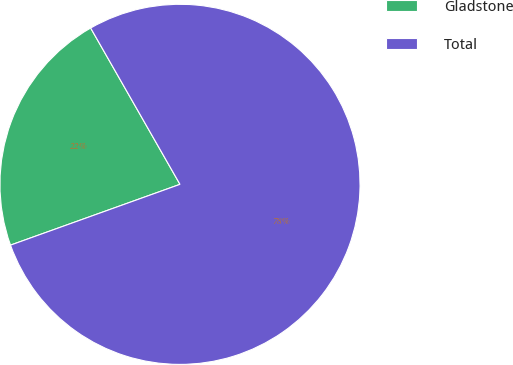Convert chart to OTSL. <chart><loc_0><loc_0><loc_500><loc_500><pie_chart><fcel>Gladstone<fcel>Total<nl><fcel>22.22%<fcel>77.78%<nl></chart> 